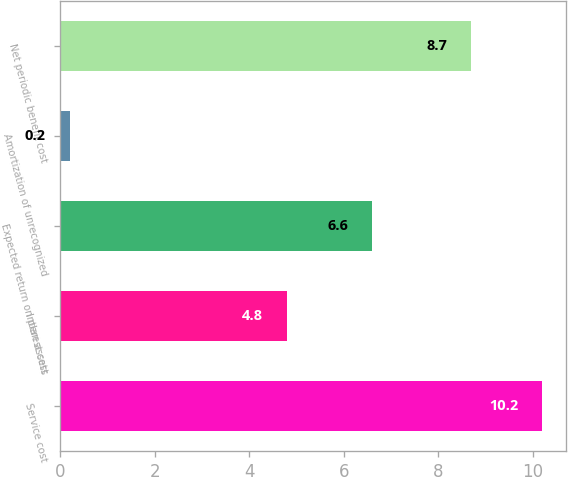Convert chart to OTSL. <chart><loc_0><loc_0><loc_500><loc_500><bar_chart><fcel>Service cost<fcel>Interest cost<fcel>Expected return on plan assets<fcel>Amortization of unrecognized<fcel>Net periodic benefit cost<nl><fcel>10.2<fcel>4.8<fcel>6.6<fcel>0.2<fcel>8.7<nl></chart> 